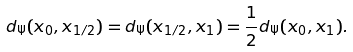<formula> <loc_0><loc_0><loc_500><loc_500>\label l { x h a l f } d _ { \Psi } ( x _ { 0 } , x _ { 1 / 2 } ) = d _ { \Psi } ( x _ { 1 / 2 } , x _ { 1 } ) = \frac { 1 } { 2 } d _ { \Psi } ( x _ { 0 } , x _ { 1 } ) .</formula> 